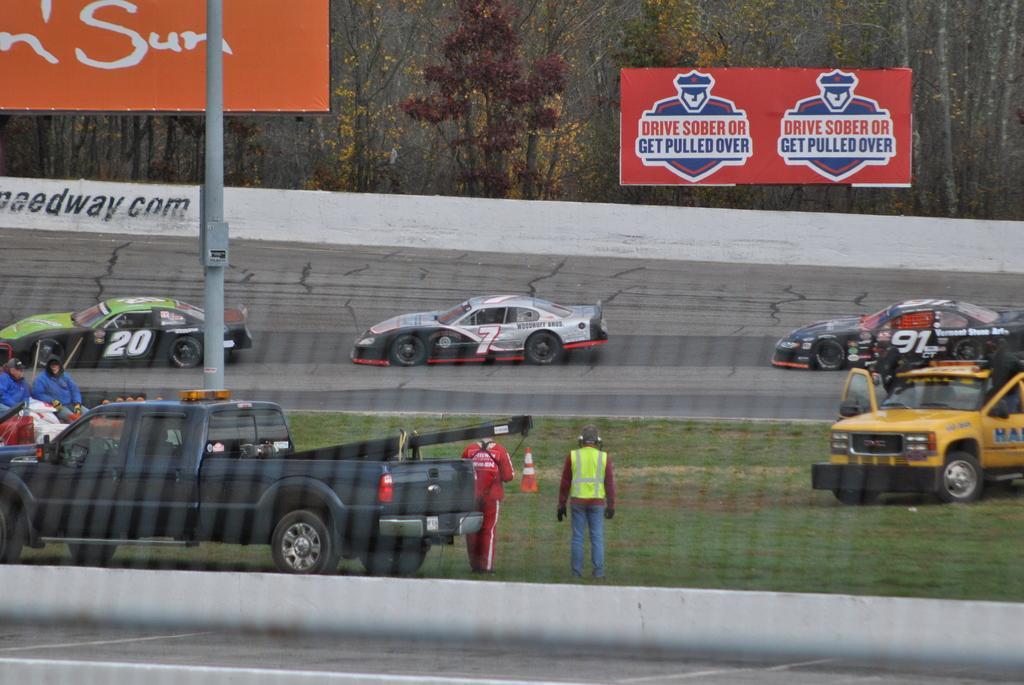How would you summarize this image in a sentence or two? In the middle of the image there are some vehicles and few people are standing and sitting. At the top of the image there are two banners and fencing. Behind the fencing there are some trees. 